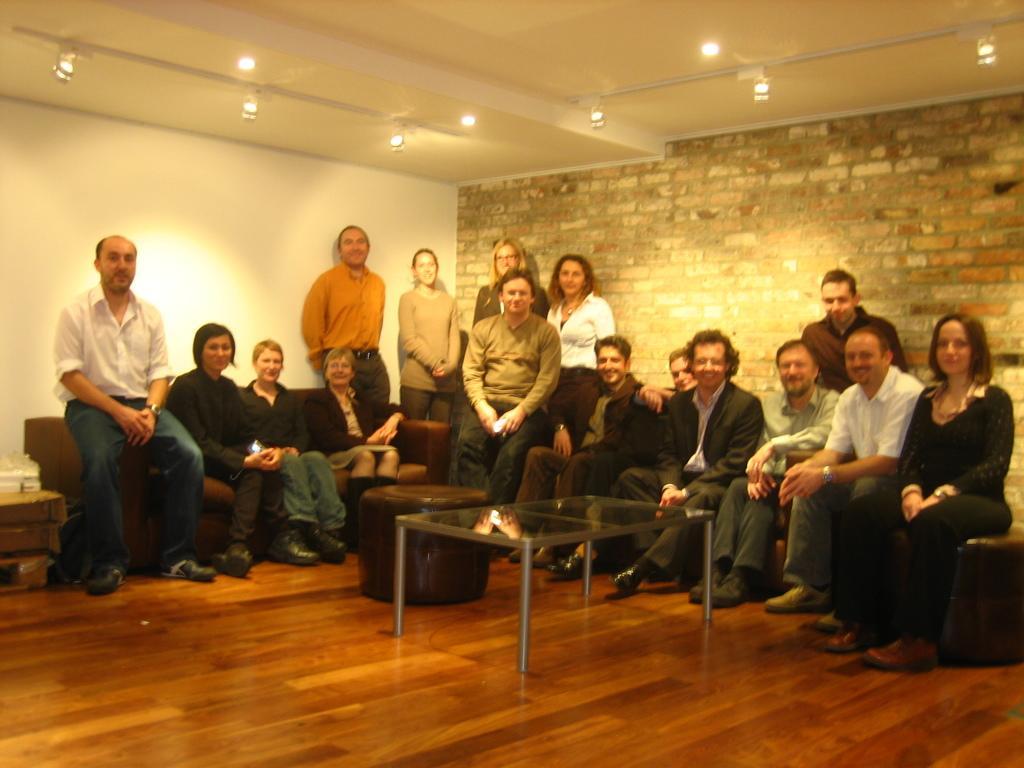Describe this image in one or two sentences. Few persons are sitting and few persons are standing. We can see sofa chairs,table on the floor. On the background we can see wall. On the top we can see lights. 